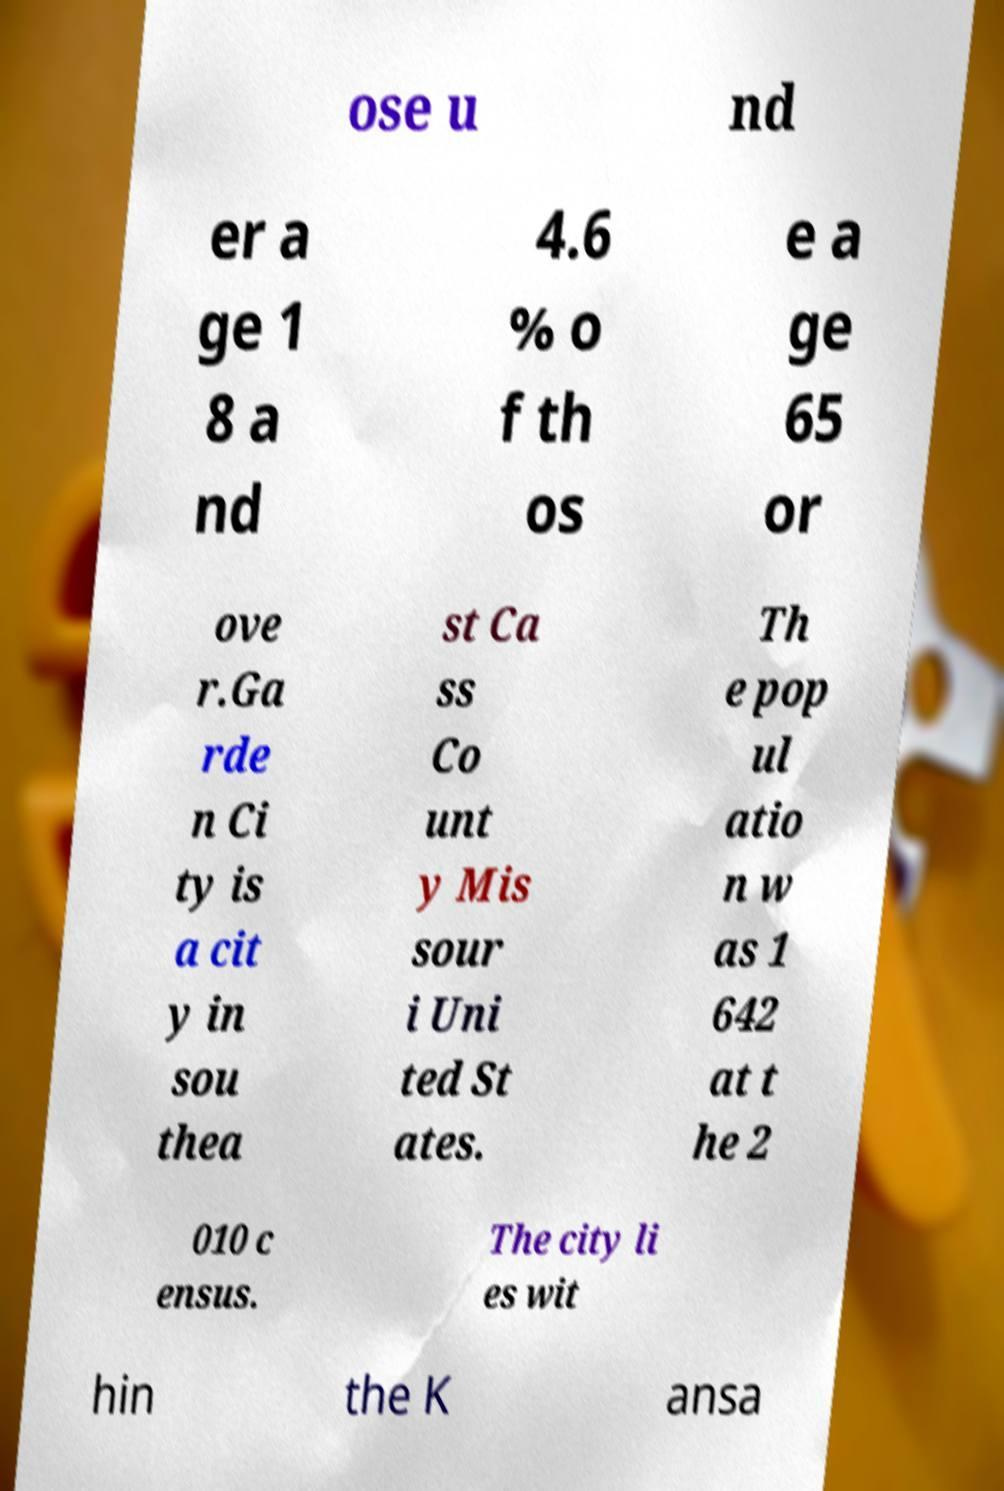For documentation purposes, I need the text within this image transcribed. Could you provide that? ose u nd er a ge 1 8 a nd 4.6 % o f th os e a ge 65 or ove r.Ga rde n Ci ty is a cit y in sou thea st Ca ss Co unt y Mis sour i Uni ted St ates. Th e pop ul atio n w as 1 642 at t he 2 010 c ensus. The city li es wit hin the K ansa 